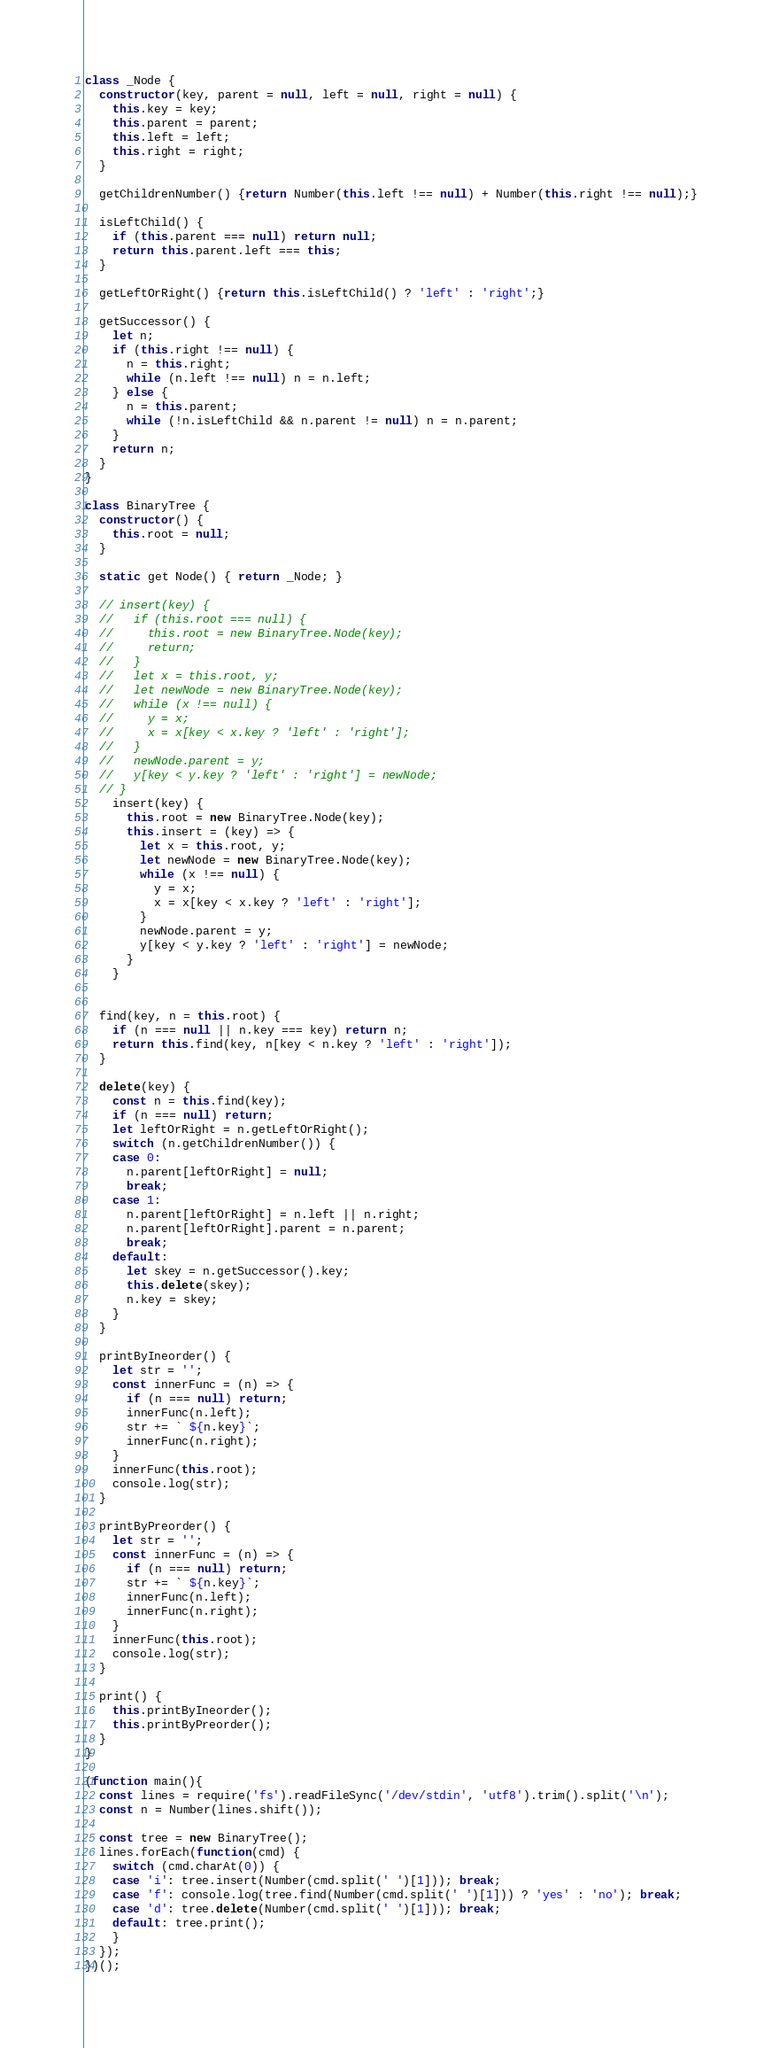Convert code to text. <code><loc_0><loc_0><loc_500><loc_500><_JavaScript_>class _Node {
  constructor(key, parent = null, left = null, right = null) {
    this.key = key;
    this.parent = parent;
    this.left = left;
    this.right = right;
  }

  getChildrenNumber() {return Number(this.left !== null) + Number(this.right !== null);}

  isLeftChild() {
    if (this.parent === null) return null;
    return this.parent.left === this;
  }

  getLeftOrRight() {return this.isLeftChild() ? 'left' : 'right';}

  getSuccessor() {
    let n;
    if (this.right !== null) {
      n = this.right;
      while (n.left !== null) n = n.left;
    } else {
      n = this.parent;
      while (!n.isLeftChild && n.parent != null) n = n.parent;
    }
    return n;
  }
}

class BinaryTree {
  constructor() {
    this.root = null;
  }

  static get Node() { return _Node; }

  // insert(key) {
  //   if (this.root === null) {
  //     this.root = new BinaryTree.Node(key);
  //     return;
  //   }
  //   let x = this.root, y;
  //   let newNode = new BinaryTree.Node(key);
  //   while (x !== null) {
  //     y = x;
  //     x = x[key < x.key ? 'left' : 'right'];
  //   }
  //   newNode.parent = y;
  //   y[key < y.key ? 'left' : 'right'] = newNode;
  // }
    insert(key) {
      this.root = new BinaryTree.Node(key);
      this.insert = (key) => {
        let x = this.root, y;
        let newNode = new BinaryTree.Node(key);
        while (x !== null) {
          y = x;
          x = x[key < x.key ? 'left' : 'right'];
        }
        newNode.parent = y;
        y[key < y.key ? 'left' : 'right'] = newNode;
      }
    }


  find(key, n = this.root) {
    if (n === null || n.key === key) return n;
    return this.find(key, n[key < n.key ? 'left' : 'right']);
  }

  delete(key) {
    const n = this.find(key);
    if (n === null) return;
    let leftOrRight = n.getLeftOrRight();
    switch (n.getChildrenNumber()) {
    case 0:
      n.parent[leftOrRight] = null;
      break;
    case 1:
      n.parent[leftOrRight] = n.left || n.right;
      n.parent[leftOrRight].parent = n.parent;
      break;
    default:
      let skey = n.getSuccessor().key;
      this.delete(skey);
      n.key = skey;
    }
  }

  printByIneorder() {
    let str = '';
    const innerFunc = (n) => {
      if (n === null) return;
      innerFunc(n.left);
      str += ` ${n.key}`;
      innerFunc(n.right);
    }
    innerFunc(this.root);
    console.log(str);
  }

  printByPreorder() {
    let str = '';
    const innerFunc = (n) => {
      if (n === null) return;
      str += ` ${n.key}`;
      innerFunc(n.left);
      innerFunc(n.right);
    }
    innerFunc(this.root);
    console.log(str);
  }

  print() {
    this.printByIneorder();
    this.printByPreorder();
  }
}

(function main(){
  const lines = require('fs').readFileSync('/dev/stdin', 'utf8').trim().split('\n');
  const n = Number(lines.shift());

  const tree = new BinaryTree();
  lines.forEach(function(cmd) {
    switch (cmd.charAt(0)) {
    case 'i': tree.insert(Number(cmd.split(' ')[1])); break;
    case 'f': console.log(tree.find(Number(cmd.split(' ')[1])) ? 'yes' : 'no'); break;
    case 'd': tree.delete(Number(cmd.split(' ')[1])); break;
    default: tree.print();
    }
  });
})();

</code> 